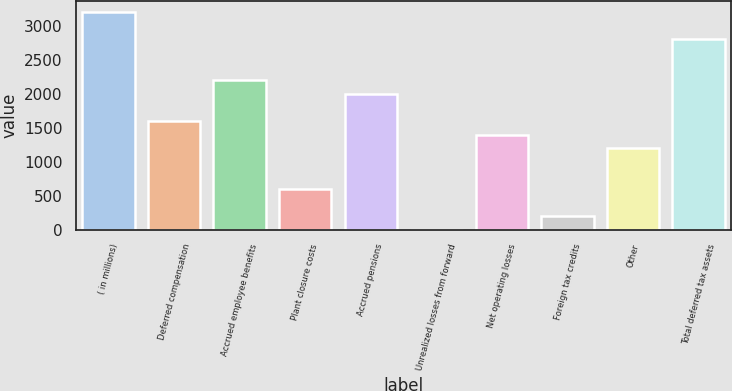Convert chart to OTSL. <chart><loc_0><loc_0><loc_500><loc_500><bar_chart><fcel>( in millions)<fcel>Deferred compensation<fcel>Accrued employee benefits<fcel>Plant closure costs<fcel>Accrued pensions<fcel>Unrealized losses from forward<fcel>Net operating losses<fcel>Foreign tax credits<fcel>Other<fcel>Total deferred tax assets<nl><fcel>3209<fcel>1605<fcel>2206.5<fcel>602.5<fcel>2006<fcel>1<fcel>1404.5<fcel>201.5<fcel>1204<fcel>2808<nl></chart> 